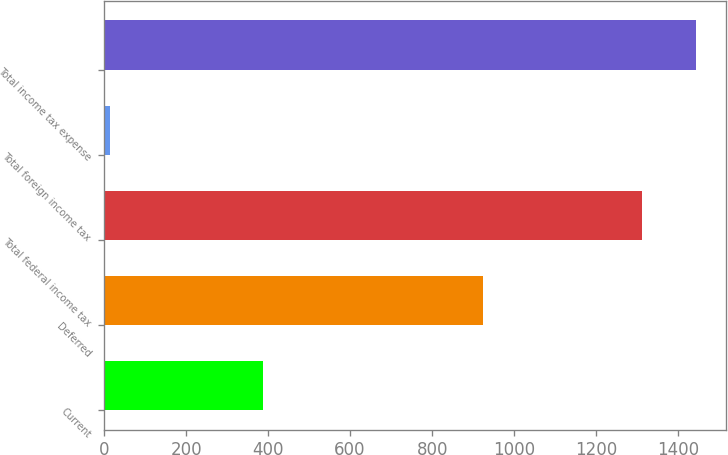Convert chart to OTSL. <chart><loc_0><loc_0><loc_500><loc_500><bar_chart><fcel>Current<fcel>Deferred<fcel>Total federal income tax<fcel>Total foreign income tax<fcel>Total income tax expense<nl><fcel>387<fcel>925<fcel>1312<fcel>15<fcel>1443.2<nl></chart> 